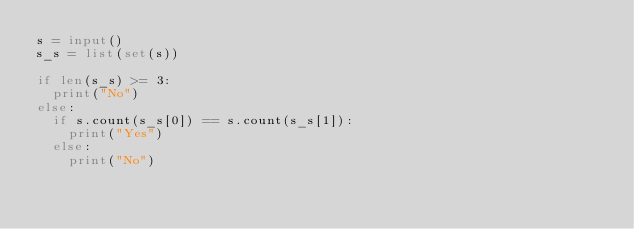Convert code to text. <code><loc_0><loc_0><loc_500><loc_500><_Python_>s = input()
s_s = list(set(s))

if len(s_s) >= 3:
  print("No")
else:
  if s.count(s_s[0]) == s.count(s_s[1]):
    print("Yes")
  else:
    print("No")</code> 